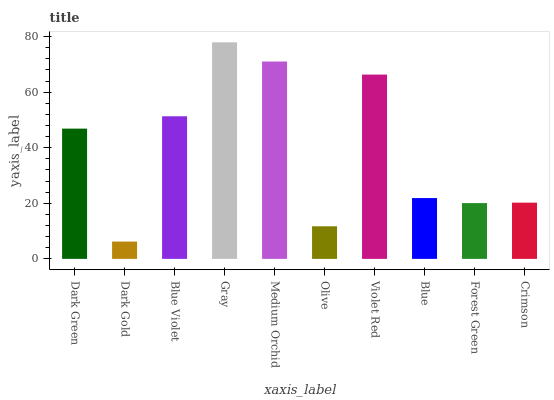Is Dark Gold the minimum?
Answer yes or no. Yes. Is Gray the maximum?
Answer yes or no. Yes. Is Blue Violet the minimum?
Answer yes or no. No. Is Blue Violet the maximum?
Answer yes or no. No. Is Blue Violet greater than Dark Gold?
Answer yes or no. Yes. Is Dark Gold less than Blue Violet?
Answer yes or no. Yes. Is Dark Gold greater than Blue Violet?
Answer yes or no. No. Is Blue Violet less than Dark Gold?
Answer yes or no. No. Is Dark Green the high median?
Answer yes or no. Yes. Is Blue the low median?
Answer yes or no. Yes. Is Olive the high median?
Answer yes or no. No. Is Gray the low median?
Answer yes or no. No. 